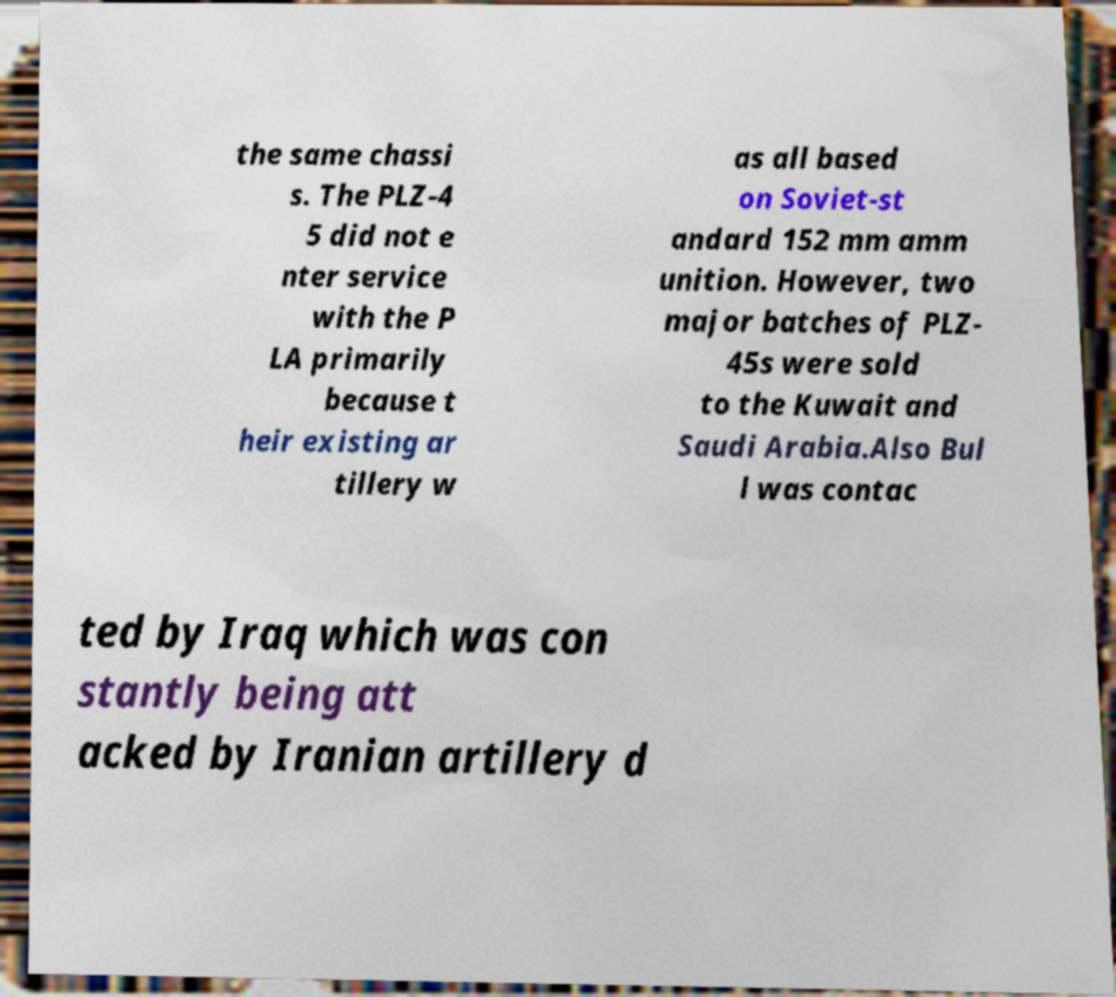What messages or text are displayed in this image? I need them in a readable, typed format. the same chassi s. The PLZ-4 5 did not e nter service with the P LA primarily because t heir existing ar tillery w as all based on Soviet-st andard 152 mm amm unition. However, two major batches of PLZ- 45s were sold to the Kuwait and Saudi Arabia.Also Bul l was contac ted by Iraq which was con stantly being att acked by Iranian artillery d 